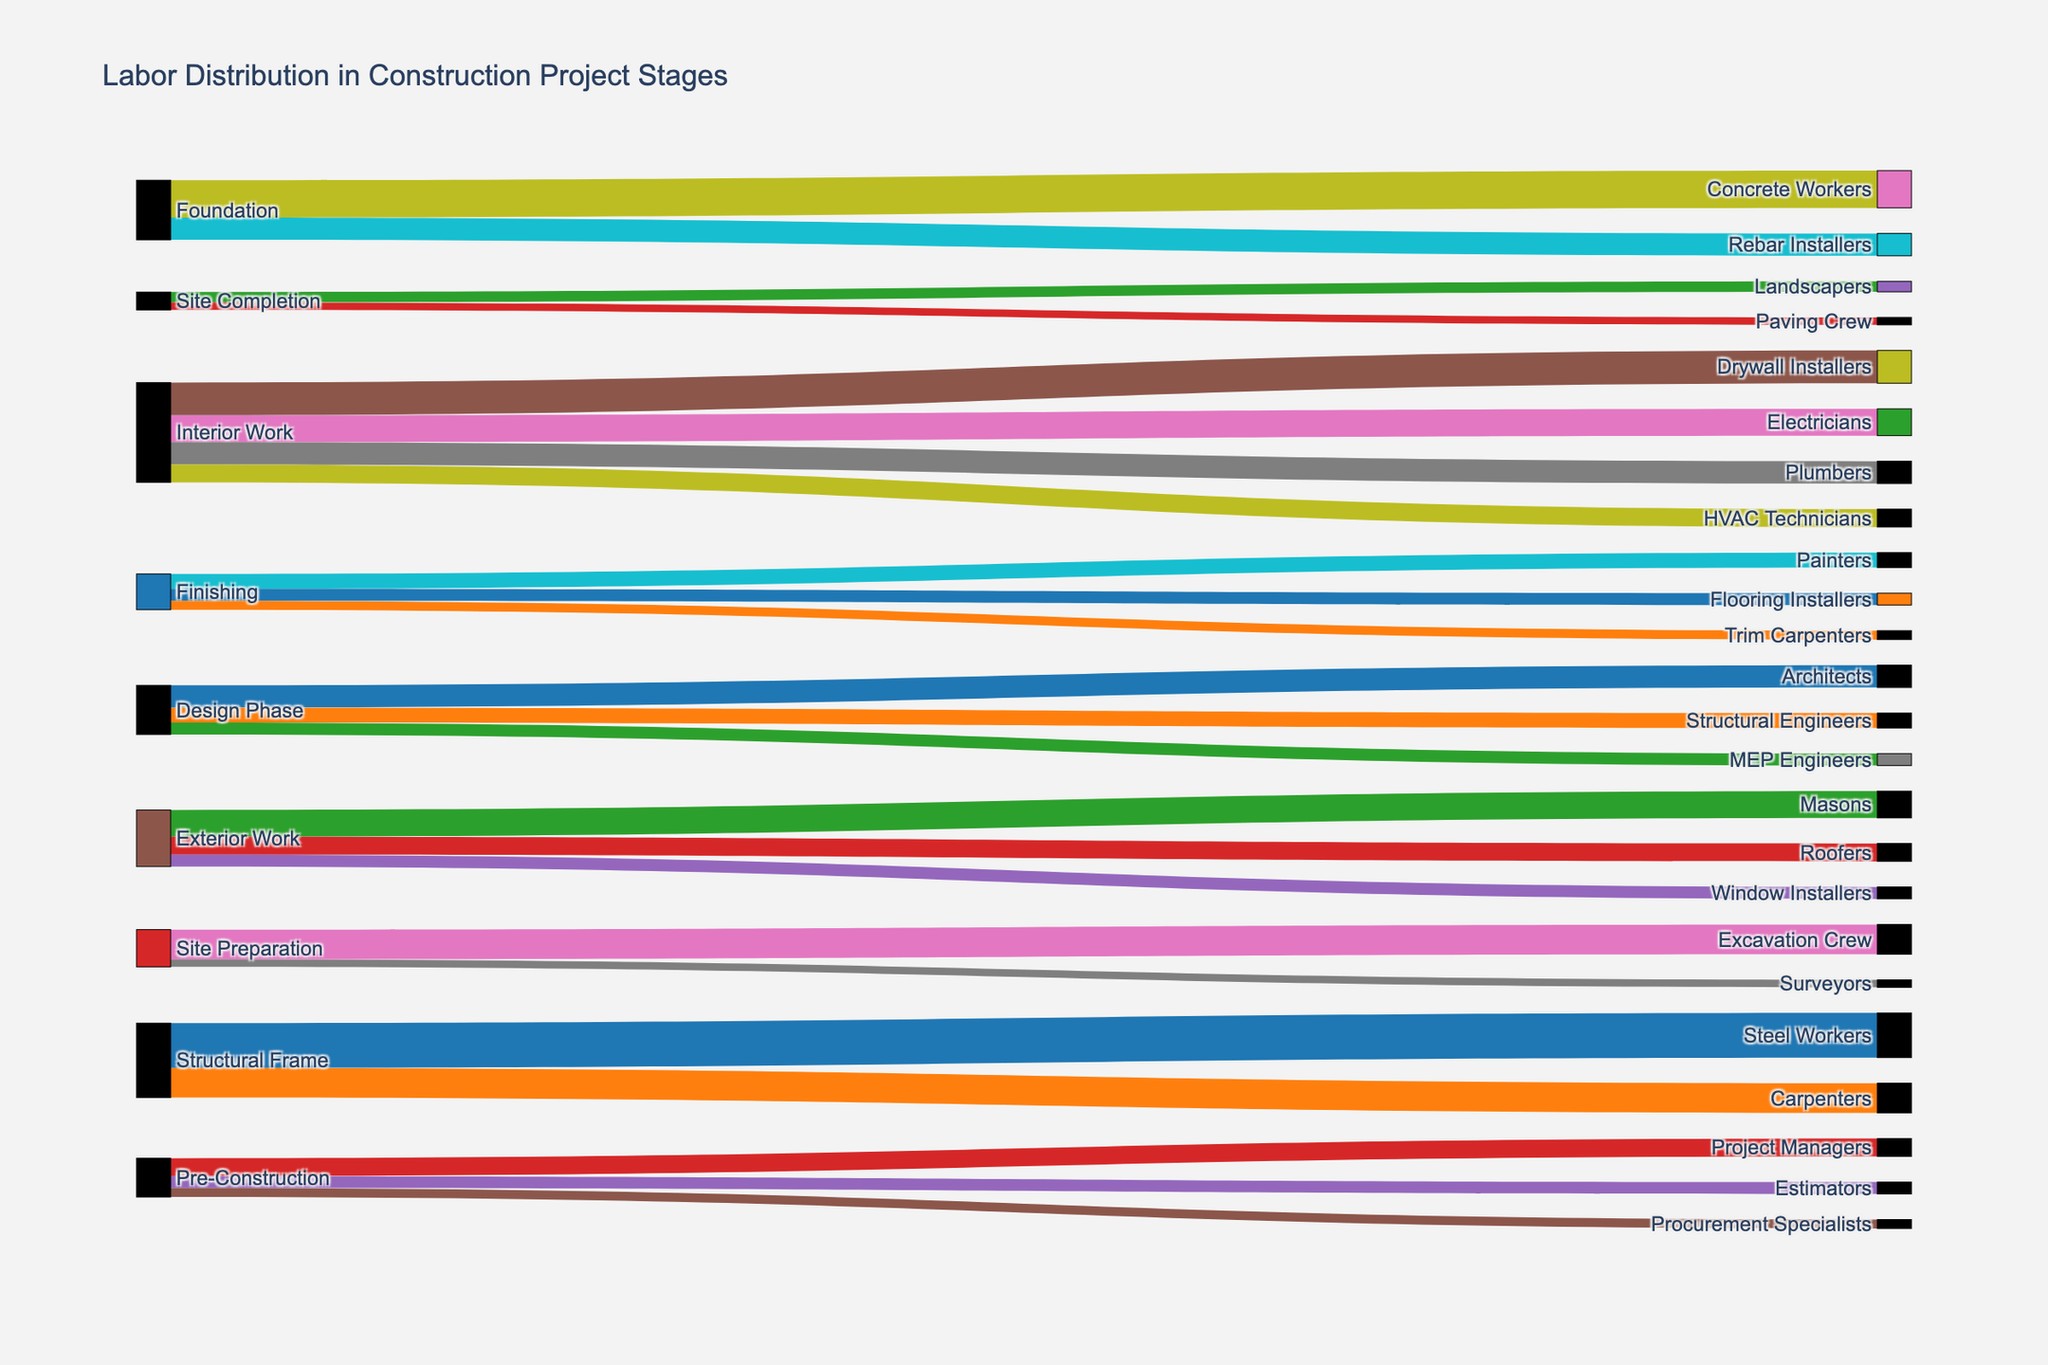What is the title of the figure? The title is usually displayed at the top of the figure; in this case, it is "Labor Distribution in Construction Project Stages."
Answer: Labor Distribution in Construction Project Stages Which phase employs the most Carpenters? To determine this, look for the connection labeled "Carpenters" in the Sankey diagram. Follow its largest connecting flow backward to find which phase it originates from.
Answer: Structural Frame How many surveyors are involved in the Site Preparation phase? Identify the "Site Preparation" phase and then trace the flow that connects it to "Surveyors." The value associated with this flow tells the number of surveyors involved.
Answer: 5 What is the total number of workers involved in the Foundation phase? This requires summing the values of all connections originating from the "Foundation" phase. Here, adding the workers for "Concrete Workers" (25) and "Rebar Installers" (15) will give the total.
Answer: 40 Which phase has the fewest unique types of workers? Count the number of distinct worker categories for each phase by examining the labels connected to each phase. The phase with the minimum distinct connections is the answer.
Answer: Site Completion Compare the number of workers in the Design Phase with those in the Pre-Construction phase. Which phase employs more workers? Sum the values of the connections originating from the "Design Phase" and compare it to the sum of the connections originating from "Pre-Construction." Design Phase: (15 + 10 + 8 = 33), Pre-Construction: (12 + 8 + 6 = 26). Therefore, the Design Phase employs more workers.
Answer: Design Phase What is the sum of the workers involved in Exterior Work? Sum up all the values of the connections from the "Exterior Work" phase. Adding the values for "Masons" (18), "Roofers" (12), and "Window Installers" (8) gives the total number of workers.
Answer: 38 Which trade has the greatest disparity in the number of workers compared to another trade within the same phase? Look for each phase and identify the largest difference in worker count between any two trades. The largest disparity is 35 (30 Steel Workers - 20 Carpenters) in the Structural Frame phase.
Answer: Steel Workers and Carpenters in Structural Frame What is the total number of HVAC Technicians and Electricians involved across all phases? Look at the flows and sum the values for "HVAC Technicians" and "Electricians." HVAC Technicians: 12, Electricians: 18. Thus, the total is (12 + 18).
Answer: 30 How does the labor distribution in the Finishing phase compare to the Site Preparation phase? Compare the sum of the values of connections from "Finishing" and "Site Preparation." Finishing: (10 + 8 + 6 = 24), Site Preparation: (20 + 5 = 25). The difference is 24 - 25, so Site Preparation has one more worker.
Answer: Site Preparation has 1 more worker 